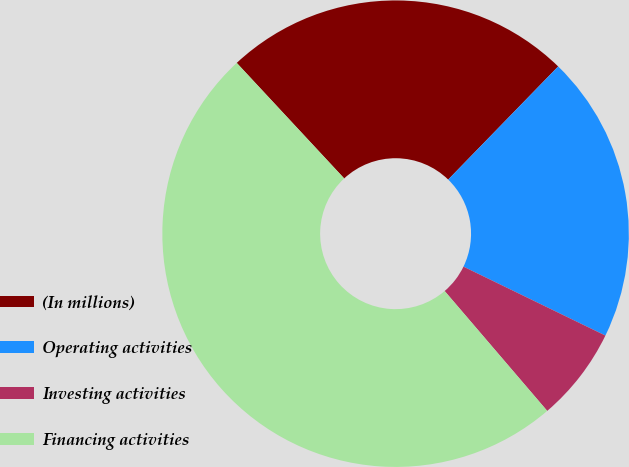Convert chart. <chart><loc_0><loc_0><loc_500><loc_500><pie_chart><fcel>(In millions)<fcel>Operating activities<fcel>Investing activities<fcel>Financing activities<nl><fcel>24.2%<fcel>19.92%<fcel>6.54%<fcel>49.34%<nl></chart> 